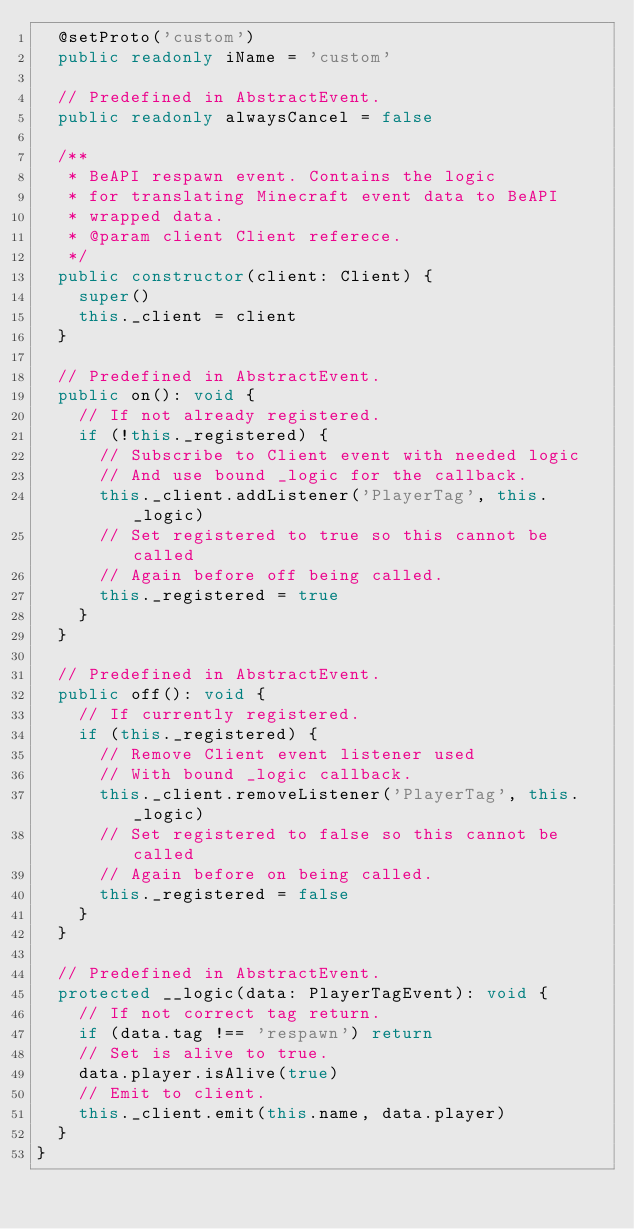Convert code to text. <code><loc_0><loc_0><loc_500><loc_500><_TypeScript_>  @setProto('custom')
  public readonly iName = 'custom'

  // Predefined in AbstractEvent.
  public readonly alwaysCancel = false

  /**
   * BeAPI respawn event. Contains the logic
   * for translating Minecraft event data to BeAPI
   * wrapped data.
   * @param client Client referece.
   */
  public constructor(client: Client) {
    super()
    this._client = client
  }

  // Predefined in AbstractEvent.
  public on(): void {
    // If not already registered.
    if (!this._registered) {
      // Subscribe to Client event with needed logic
      // And use bound _logic for the callback.
      this._client.addListener('PlayerTag', this._logic)
      // Set registered to true so this cannot be called
      // Again before off being called.
      this._registered = true
    }
  }

  // Predefined in AbstractEvent.
  public off(): void {
    // If currently registered.
    if (this._registered) {
      // Remove Client event listener used
      // With bound _logic callback.
      this._client.removeListener('PlayerTag', this._logic)
      // Set registered to false so this cannot be called
      // Again before on being called.
      this._registered = false
    }
  }

  // Predefined in AbstractEvent.
  protected __logic(data: PlayerTagEvent): void {
    // If not correct tag return.
    if (data.tag !== 'respawn') return
    // Set is alive to true.
    data.player.isAlive(true)
    // Emit to client.
    this._client.emit(this.name, data.player)
  }
}
</code> 